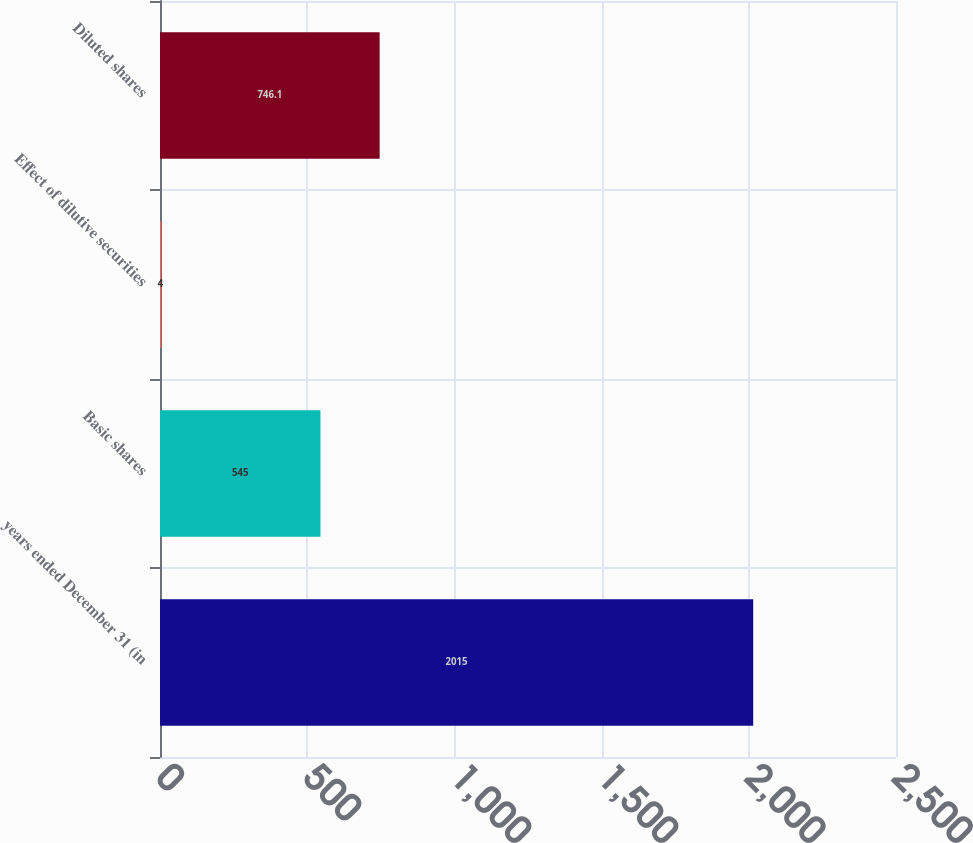Convert chart. <chart><loc_0><loc_0><loc_500><loc_500><bar_chart><fcel>years ended December 31 (in<fcel>Basic shares<fcel>Effect of dilutive securities<fcel>Diluted shares<nl><fcel>2015<fcel>545<fcel>4<fcel>746.1<nl></chart> 